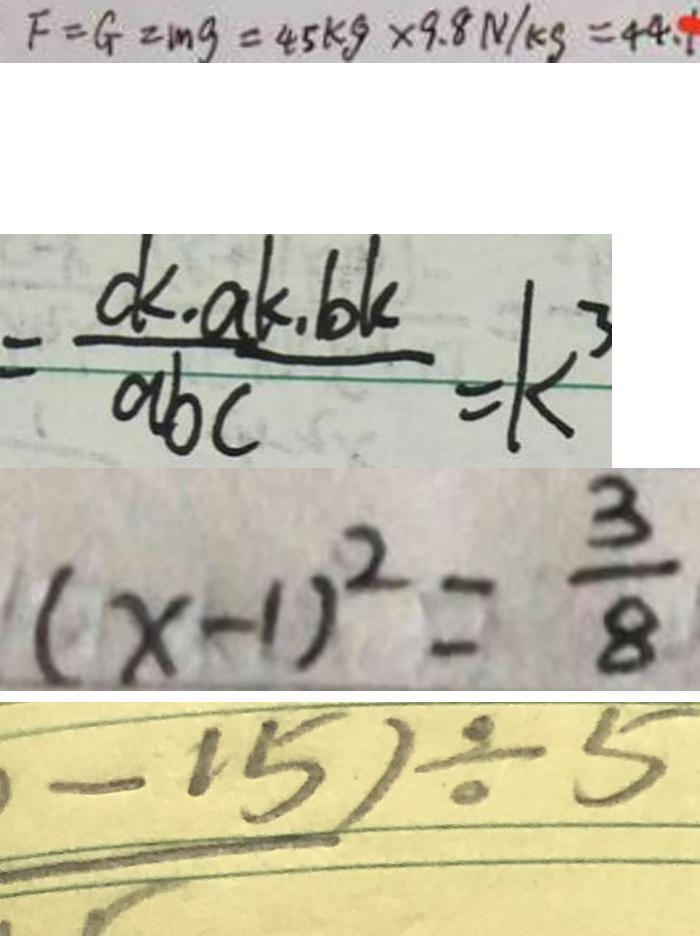<formula> <loc_0><loc_0><loc_500><loc_500>F = G = m g = 4 5 k g \times 9 . 8 N / k g = 4 4 . 1 
 = \frac { d < a k . b k } { a b c } = k ^ { 3 } 
 ( x - 1 ) ^ { 2 } = \frac { 3 } { 8 } 
 - 1 5 ) \div 5</formula> 